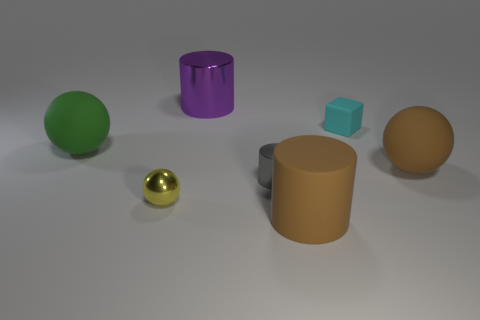Subtract all small gray metal cylinders. How many cylinders are left? 2 Subtract all yellow balls. How many balls are left? 2 Subtract 2 cylinders. How many cylinders are left? 1 Add 3 purple shiny cylinders. How many objects exist? 10 Subtract all cylinders. How many objects are left? 4 Subtract all gray blocks. Subtract all yellow spheres. How many blocks are left? 1 Subtract all small brown rubber cylinders. Subtract all large green balls. How many objects are left? 6 Add 7 brown rubber things. How many brown rubber things are left? 9 Add 6 small rubber objects. How many small rubber objects exist? 7 Subtract 1 yellow balls. How many objects are left? 6 